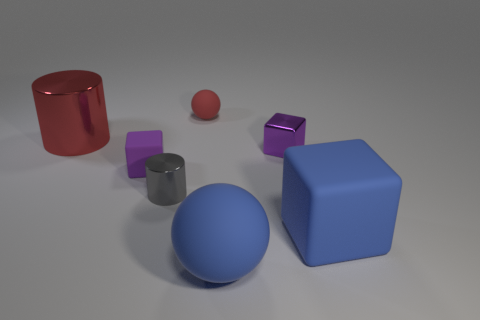Are there more large blue spheres to the left of the big cube than red rubber objects in front of the large rubber ball?
Your answer should be compact. Yes. What is the size of the cylinder that is the same color as the tiny ball?
Give a very brief answer. Large. The large cube has what color?
Keep it short and to the point. Blue. What color is the object that is both behind the small shiny cube and to the right of the large red shiny object?
Ensure brevity in your answer.  Red. There is a ball that is on the left side of the blue matte thing that is in front of the matte cube that is on the right side of the gray object; what color is it?
Make the answer very short. Red. There is another metallic object that is the same size as the gray thing; what is its color?
Provide a short and direct response. Purple. What is the shape of the large thing that is behind the large object on the right side of the blue thing in front of the large cube?
Offer a terse response. Cylinder. There is a small thing that is the same color as the large metallic cylinder; what shape is it?
Your response must be concise. Sphere. What number of objects are large blue matte objects or blue matte things to the left of the big blue block?
Give a very brief answer. 2. There is a red object left of the purple matte object; is it the same size as the large matte ball?
Make the answer very short. Yes. 